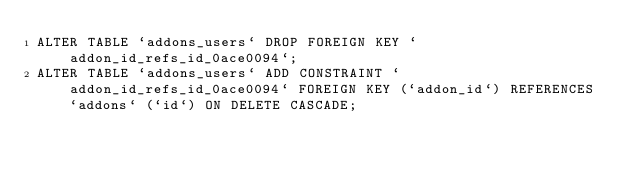Convert code to text. <code><loc_0><loc_0><loc_500><loc_500><_SQL_>ALTER TABLE `addons_users` DROP FOREIGN KEY `addon_id_refs_id_0ace0094`;
ALTER TABLE `addons_users` ADD CONSTRAINT `addon_id_refs_id_0ace0094` FOREIGN KEY (`addon_id`) REFERENCES `addons` (`id`) ON DELETE CASCADE;
</code> 